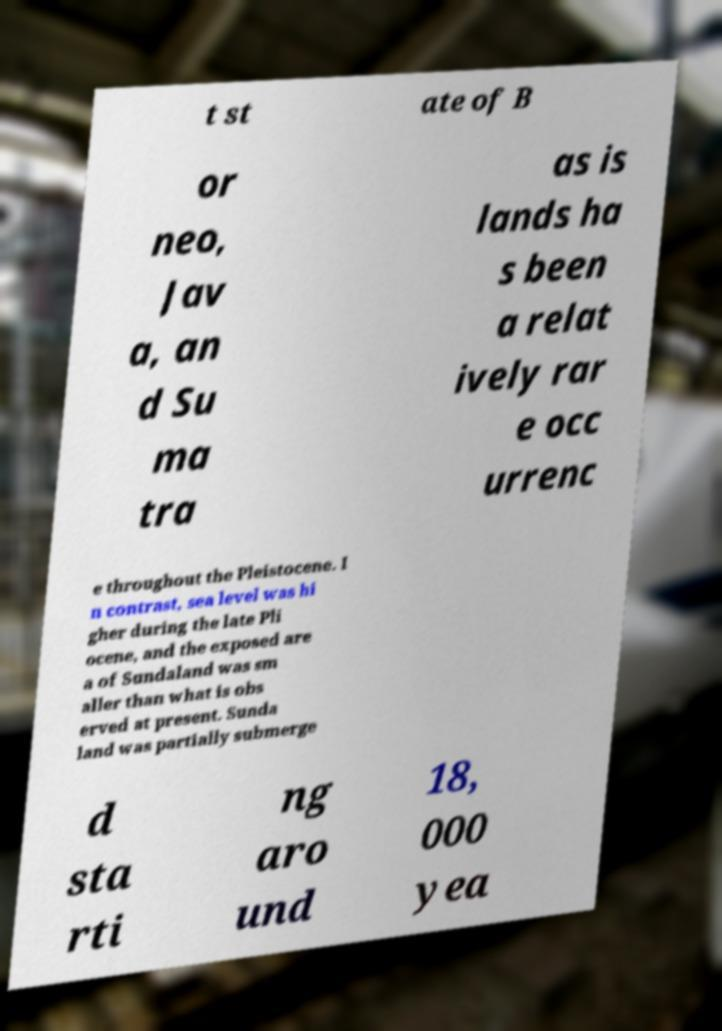What messages or text are displayed in this image? I need them in a readable, typed format. t st ate of B or neo, Jav a, an d Su ma tra as is lands ha s been a relat ively rar e occ urrenc e throughout the Pleistocene. I n contrast, sea level was hi gher during the late Pli ocene, and the exposed are a of Sundaland was sm aller than what is obs erved at present. Sunda land was partially submerge d sta rti ng aro und 18, 000 yea 